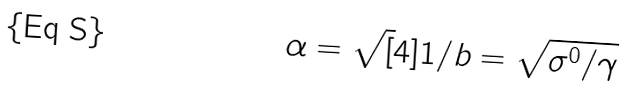<formula> <loc_0><loc_0><loc_500><loc_500>\alpha = \sqrt { [ } 4 ] { 1 / b } = \sqrt { \sigma ^ { 0 } / \gamma }</formula> 